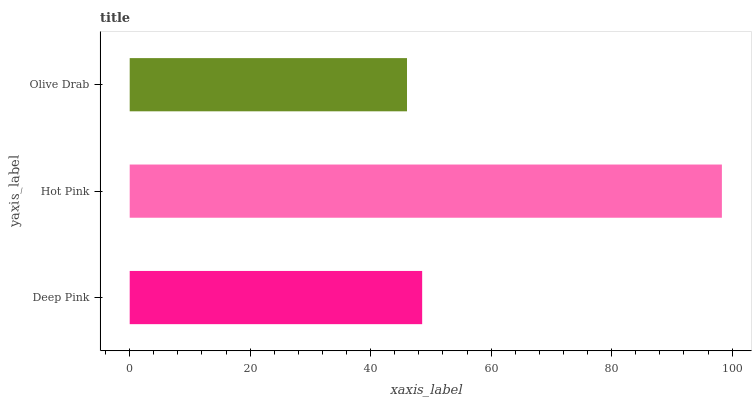Is Olive Drab the minimum?
Answer yes or no. Yes. Is Hot Pink the maximum?
Answer yes or no. Yes. Is Hot Pink the minimum?
Answer yes or no. No. Is Olive Drab the maximum?
Answer yes or no. No. Is Hot Pink greater than Olive Drab?
Answer yes or no. Yes. Is Olive Drab less than Hot Pink?
Answer yes or no. Yes. Is Olive Drab greater than Hot Pink?
Answer yes or no. No. Is Hot Pink less than Olive Drab?
Answer yes or no. No. Is Deep Pink the high median?
Answer yes or no. Yes. Is Deep Pink the low median?
Answer yes or no. Yes. Is Hot Pink the high median?
Answer yes or no. No. Is Olive Drab the low median?
Answer yes or no. No. 